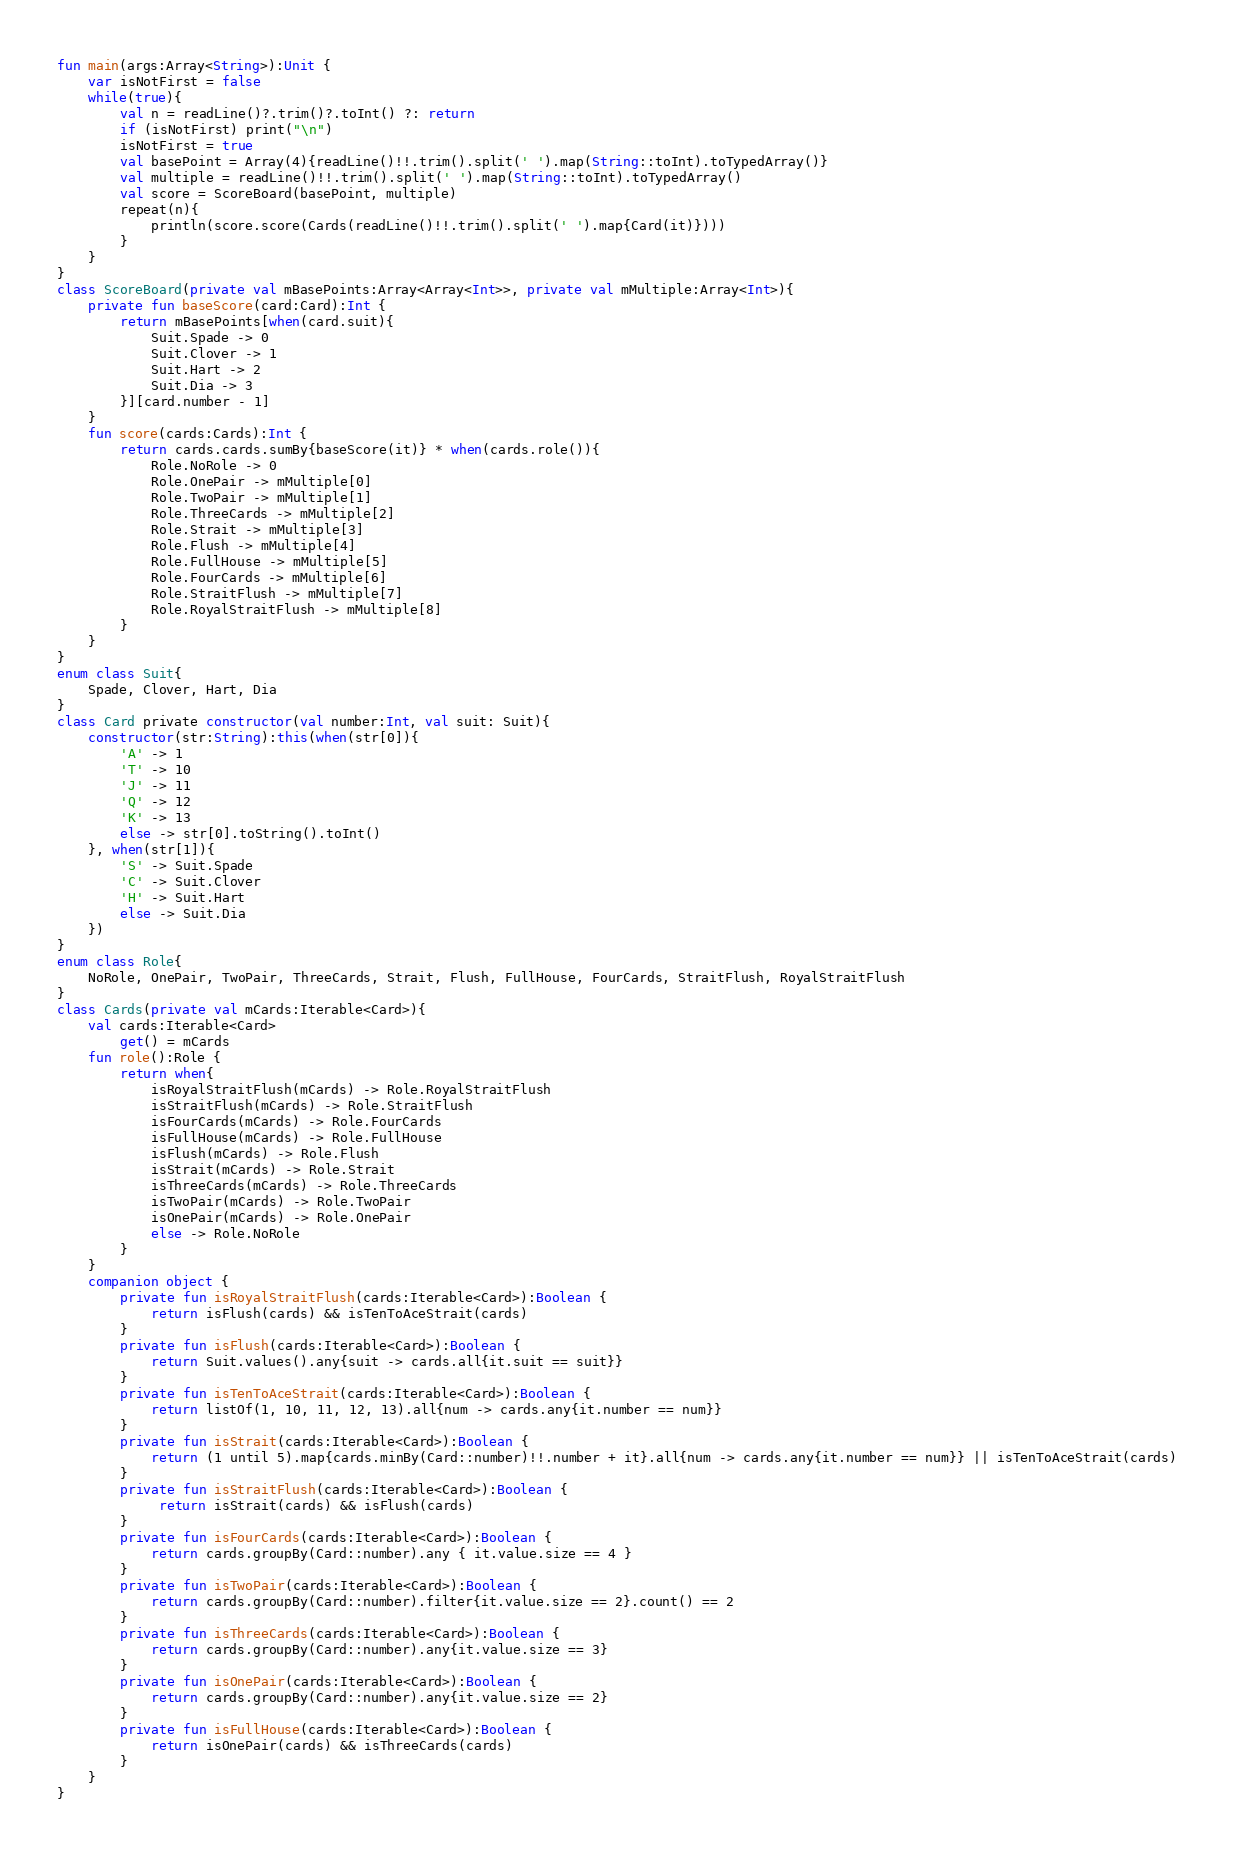<code> <loc_0><loc_0><loc_500><loc_500><_Kotlin_>
fun main(args:Array<String>):Unit {
    var isNotFirst = false
    while(true){
        val n = readLine()?.trim()?.toInt() ?: return
        if (isNotFirst) print("\n")
        isNotFirst = true
        val basePoint = Array(4){readLine()!!.trim().split(' ').map(String::toInt).toTypedArray()}
        val multiple = readLine()!!.trim().split(' ').map(String::toInt).toTypedArray()
        val score = ScoreBoard(basePoint, multiple)
        repeat(n){
            println(score.score(Cards(readLine()!!.trim().split(' ').map{Card(it)})))
        }
    }
}
class ScoreBoard(private val mBasePoints:Array<Array<Int>>, private val mMultiple:Array<Int>){
    private fun baseScore(card:Card):Int {
        return mBasePoints[when(card.suit){
            Suit.Spade -> 0
            Suit.Clover -> 1
            Suit.Hart -> 2
            Suit.Dia -> 3
        }][card.number - 1]
    }
    fun score(cards:Cards):Int {
        return cards.cards.sumBy{baseScore(it)} * when(cards.role()){
            Role.NoRole -> 0
            Role.OnePair -> mMultiple[0]
            Role.TwoPair -> mMultiple[1]
            Role.ThreeCards -> mMultiple[2]
            Role.Strait -> mMultiple[3]
            Role.Flush -> mMultiple[4]
            Role.FullHouse -> mMultiple[5]
            Role.FourCards -> mMultiple[6]
            Role.StraitFlush -> mMultiple[7]
            Role.RoyalStraitFlush -> mMultiple[8]
        }
    }
}
enum class Suit{
    Spade, Clover, Hart, Dia
}
class Card private constructor(val number:Int, val suit: Suit){
    constructor(str:String):this(when(str[0]){
        'A' -> 1
        'T' -> 10
        'J' -> 11
        'Q' -> 12
        'K' -> 13
        else -> str[0].toString().toInt()
    }, when(str[1]){
        'S' -> Suit.Spade
        'C' -> Suit.Clover
        'H' -> Suit.Hart
        else -> Suit.Dia
    })
}
enum class Role{
    NoRole, OnePair, TwoPair, ThreeCards, Strait, Flush, FullHouse, FourCards, StraitFlush, RoyalStraitFlush
}
class Cards(private val mCards:Iterable<Card>){
    val cards:Iterable<Card>
        get() = mCards
    fun role():Role {
        return when{
            isRoyalStraitFlush(mCards) -> Role.RoyalStraitFlush
            isStraitFlush(mCards) -> Role.StraitFlush
            isFourCards(mCards) -> Role.FourCards
            isFullHouse(mCards) -> Role.FullHouse
            isFlush(mCards) -> Role.Flush
            isStrait(mCards) -> Role.Strait
            isThreeCards(mCards) -> Role.ThreeCards
            isTwoPair(mCards) -> Role.TwoPair
            isOnePair(mCards) -> Role.OnePair
            else -> Role.NoRole
        }
    }
    companion object {
        private fun isRoyalStraitFlush(cards:Iterable<Card>):Boolean {
            return isFlush(cards) && isTenToAceStrait(cards)
        }
        private fun isFlush(cards:Iterable<Card>):Boolean {
            return Suit.values().any{suit -> cards.all{it.suit == suit}}
        }
        private fun isTenToAceStrait(cards:Iterable<Card>):Boolean {
            return listOf(1, 10, 11, 12, 13).all{num -> cards.any{it.number == num}}
        }
        private fun isStrait(cards:Iterable<Card>):Boolean {
            return (1 until 5).map{cards.minBy(Card::number)!!.number + it}.all{num -> cards.any{it.number == num}} || isTenToAceStrait(cards)
        }
        private fun isStraitFlush(cards:Iterable<Card>):Boolean {
             return isStrait(cards) && isFlush(cards)
        }
        private fun isFourCards(cards:Iterable<Card>):Boolean {
            return cards.groupBy(Card::number).any { it.value.size == 4 }
        }
        private fun isTwoPair(cards:Iterable<Card>):Boolean {
            return cards.groupBy(Card::number).filter{it.value.size == 2}.count() == 2
        }
        private fun isThreeCards(cards:Iterable<Card>):Boolean {
            return cards.groupBy(Card::number).any{it.value.size == 3}
        }
        private fun isOnePair(cards:Iterable<Card>):Boolean {
            return cards.groupBy(Card::number).any{it.value.size == 2}
        }
        private fun isFullHouse(cards:Iterable<Card>):Boolean {
            return isOnePair(cards) && isThreeCards(cards)
        }
    }
}
</code> 